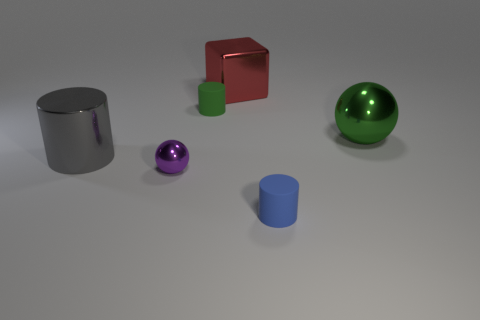Add 4 cubes. How many objects exist? 10 Subtract all balls. How many objects are left? 4 Add 2 purple cubes. How many purple cubes exist? 2 Subtract 0 cyan cubes. How many objects are left? 6 Subtract all tiny purple things. Subtract all tiny purple metal things. How many objects are left? 4 Add 1 small blue rubber objects. How many small blue rubber objects are left? 2 